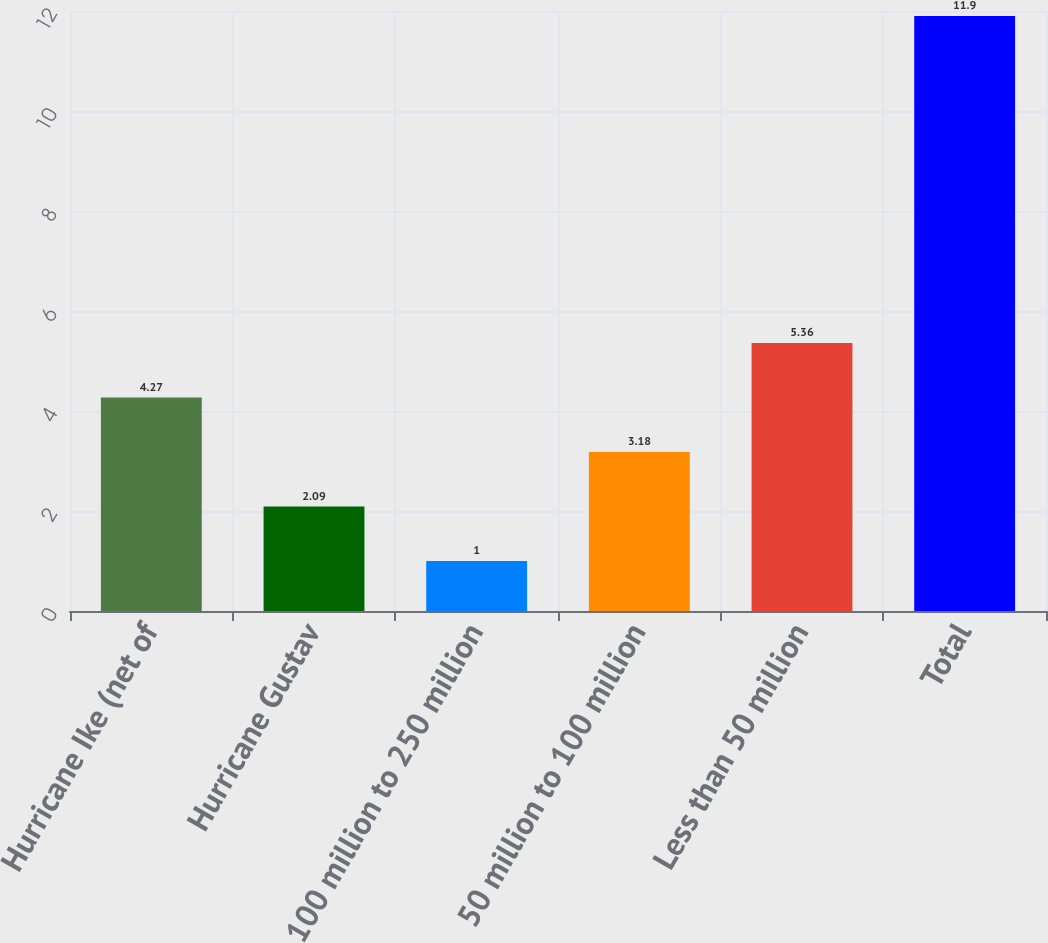Convert chart to OTSL. <chart><loc_0><loc_0><loc_500><loc_500><bar_chart><fcel>Hurricane Ike (net of<fcel>Hurricane Gustav<fcel>100 million to 250 million<fcel>50 million to 100 million<fcel>Less than 50 million<fcel>Total<nl><fcel>4.27<fcel>2.09<fcel>1<fcel>3.18<fcel>5.36<fcel>11.9<nl></chart> 